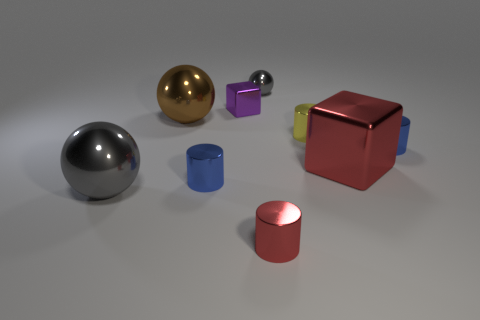There is a object that is the same color as the small ball; what is its material?
Your answer should be compact. Metal. Does the ball in front of the small yellow thing have the same color as the tiny sphere?
Give a very brief answer. Yes. What number of other things are the same color as the big metallic block?
Ensure brevity in your answer.  1. How many objects are blue metallic objects or large objects in front of the brown metallic thing?
Keep it short and to the point. 4. What is the size of the red cylinder that is made of the same material as the purple cube?
Offer a very short reply. Small. There is a metal thing that is behind the metallic block to the left of the small metal sphere; what is its shape?
Your answer should be compact. Sphere. There is a sphere that is behind the small yellow cylinder and in front of the purple thing; how big is it?
Your answer should be very brief. Large. Is there another brown thing that has the same shape as the big brown metal thing?
Your answer should be very brief. No. The big thing that is behind the blue shiny cylinder to the right of the gray metallic ball that is to the right of the purple object is made of what material?
Your response must be concise. Metal. Are there any green shiny balls of the same size as the purple shiny cube?
Make the answer very short. No. 